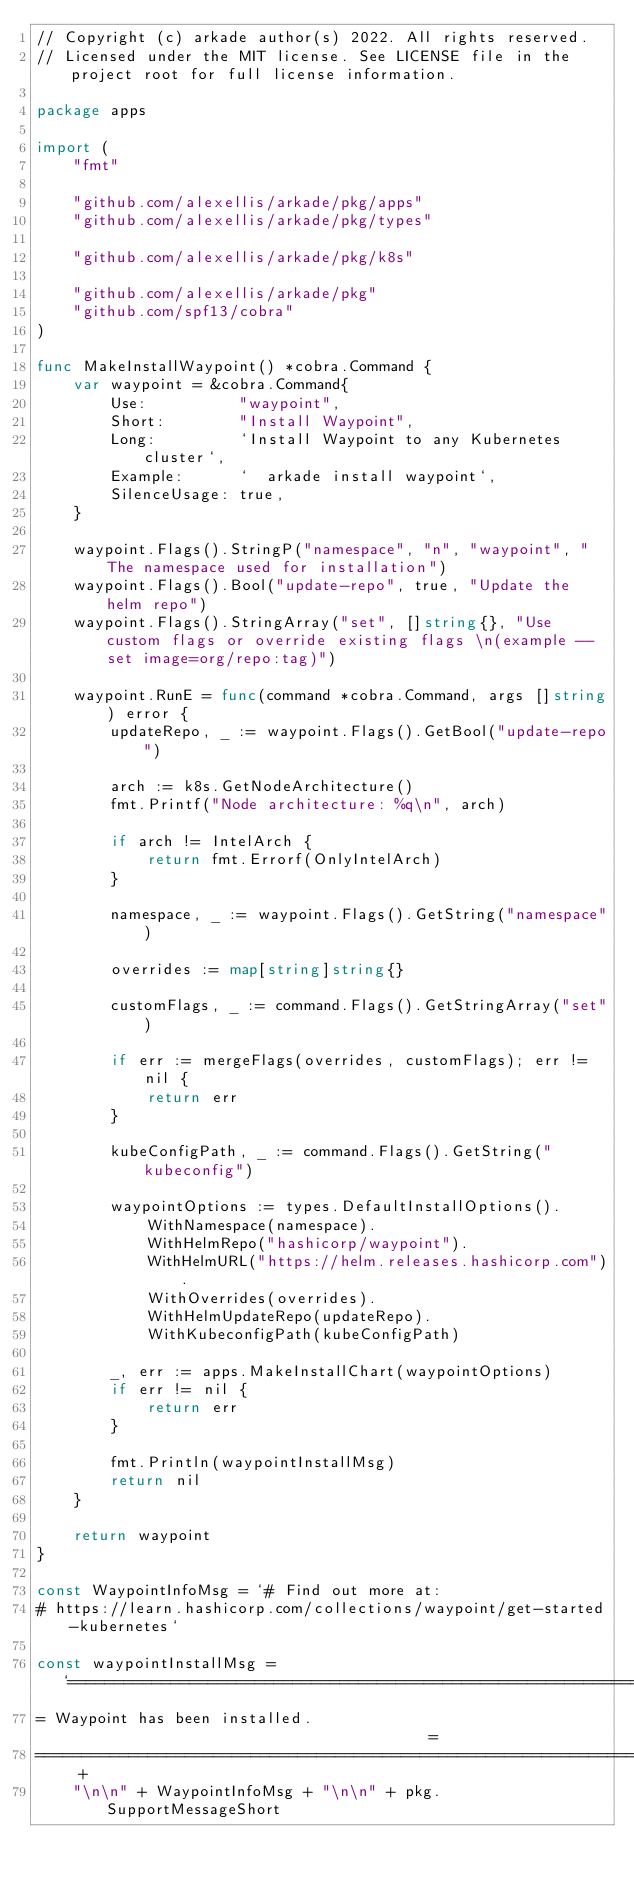Convert code to text. <code><loc_0><loc_0><loc_500><loc_500><_Go_>// Copyright (c) arkade author(s) 2022. All rights reserved.
// Licensed under the MIT license. See LICENSE file in the project root for full license information.

package apps

import (
	"fmt"

	"github.com/alexellis/arkade/pkg/apps"
	"github.com/alexellis/arkade/pkg/types"

	"github.com/alexellis/arkade/pkg/k8s"

	"github.com/alexellis/arkade/pkg"
	"github.com/spf13/cobra"
)

func MakeInstallWaypoint() *cobra.Command {
	var waypoint = &cobra.Command{
		Use:          "waypoint",
		Short:        "Install Waypoint",
		Long:         `Install Waypoint to any Kubernetes cluster`,
		Example:      `  arkade install waypoint`,
		SilenceUsage: true,
	}

	waypoint.Flags().StringP("namespace", "n", "waypoint", "The namespace used for installation")
	waypoint.Flags().Bool("update-repo", true, "Update the helm repo")
	waypoint.Flags().StringArray("set", []string{}, "Use custom flags or override existing flags \n(example --set image=org/repo:tag)")

	waypoint.RunE = func(command *cobra.Command, args []string) error {
		updateRepo, _ := waypoint.Flags().GetBool("update-repo")

		arch := k8s.GetNodeArchitecture()
		fmt.Printf("Node architecture: %q\n", arch)

		if arch != IntelArch {
			return fmt.Errorf(OnlyIntelArch)
		}

		namespace, _ := waypoint.Flags().GetString("namespace")

		overrides := map[string]string{}

		customFlags, _ := command.Flags().GetStringArray("set")

		if err := mergeFlags(overrides, customFlags); err != nil {
			return err
		}

		kubeConfigPath, _ := command.Flags().GetString("kubeconfig")

		waypointOptions := types.DefaultInstallOptions().
			WithNamespace(namespace).
			WithHelmRepo("hashicorp/waypoint").
			WithHelmURL("https://helm.releases.hashicorp.com").
			WithOverrides(overrides).
			WithHelmUpdateRepo(updateRepo).
			WithKubeconfigPath(kubeConfigPath)

		_, err := apps.MakeInstallChart(waypointOptions)
		if err != nil {
			return err
		}

		fmt.Println(waypointInstallMsg)
		return nil
	}

	return waypoint
}

const WaypointInfoMsg = `# Find out more at:
# https://learn.hashicorp.com/collections/waypoint/get-started-kubernetes`

const waypointInstallMsg = `=======================================================================
= Waypoint has been installed.                                        =
=======================================================================` +
	"\n\n" + WaypointInfoMsg + "\n\n" + pkg.SupportMessageShort
</code> 